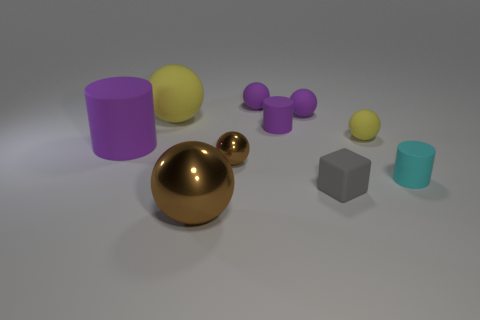Subtract all yellow cylinders. How many brown balls are left? 2 Subtract all purple matte cylinders. How many cylinders are left? 1 Subtract all brown balls. How many balls are left? 4 Subtract 4 spheres. How many spheres are left? 2 Subtract all gray spheres. Subtract all purple cubes. How many spheres are left? 6 Subtract all balls. How many objects are left? 4 Subtract 0 cyan blocks. How many objects are left? 10 Subtract all matte cubes. Subtract all rubber spheres. How many objects are left? 5 Add 6 purple rubber cylinders. How many purple rubber cylinders are left? 8 Add 8 tiny matte cylinders. How many tiny matte cylinders exist? 10 